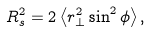<formula> <loc_0><loc_0><loc_500><loc_500>R _ { s } ^ { 2 } = 2 \left < r _ { \perp } ^ { 2 } \sin ^ { 2 } \phi \right > ,</formula> 